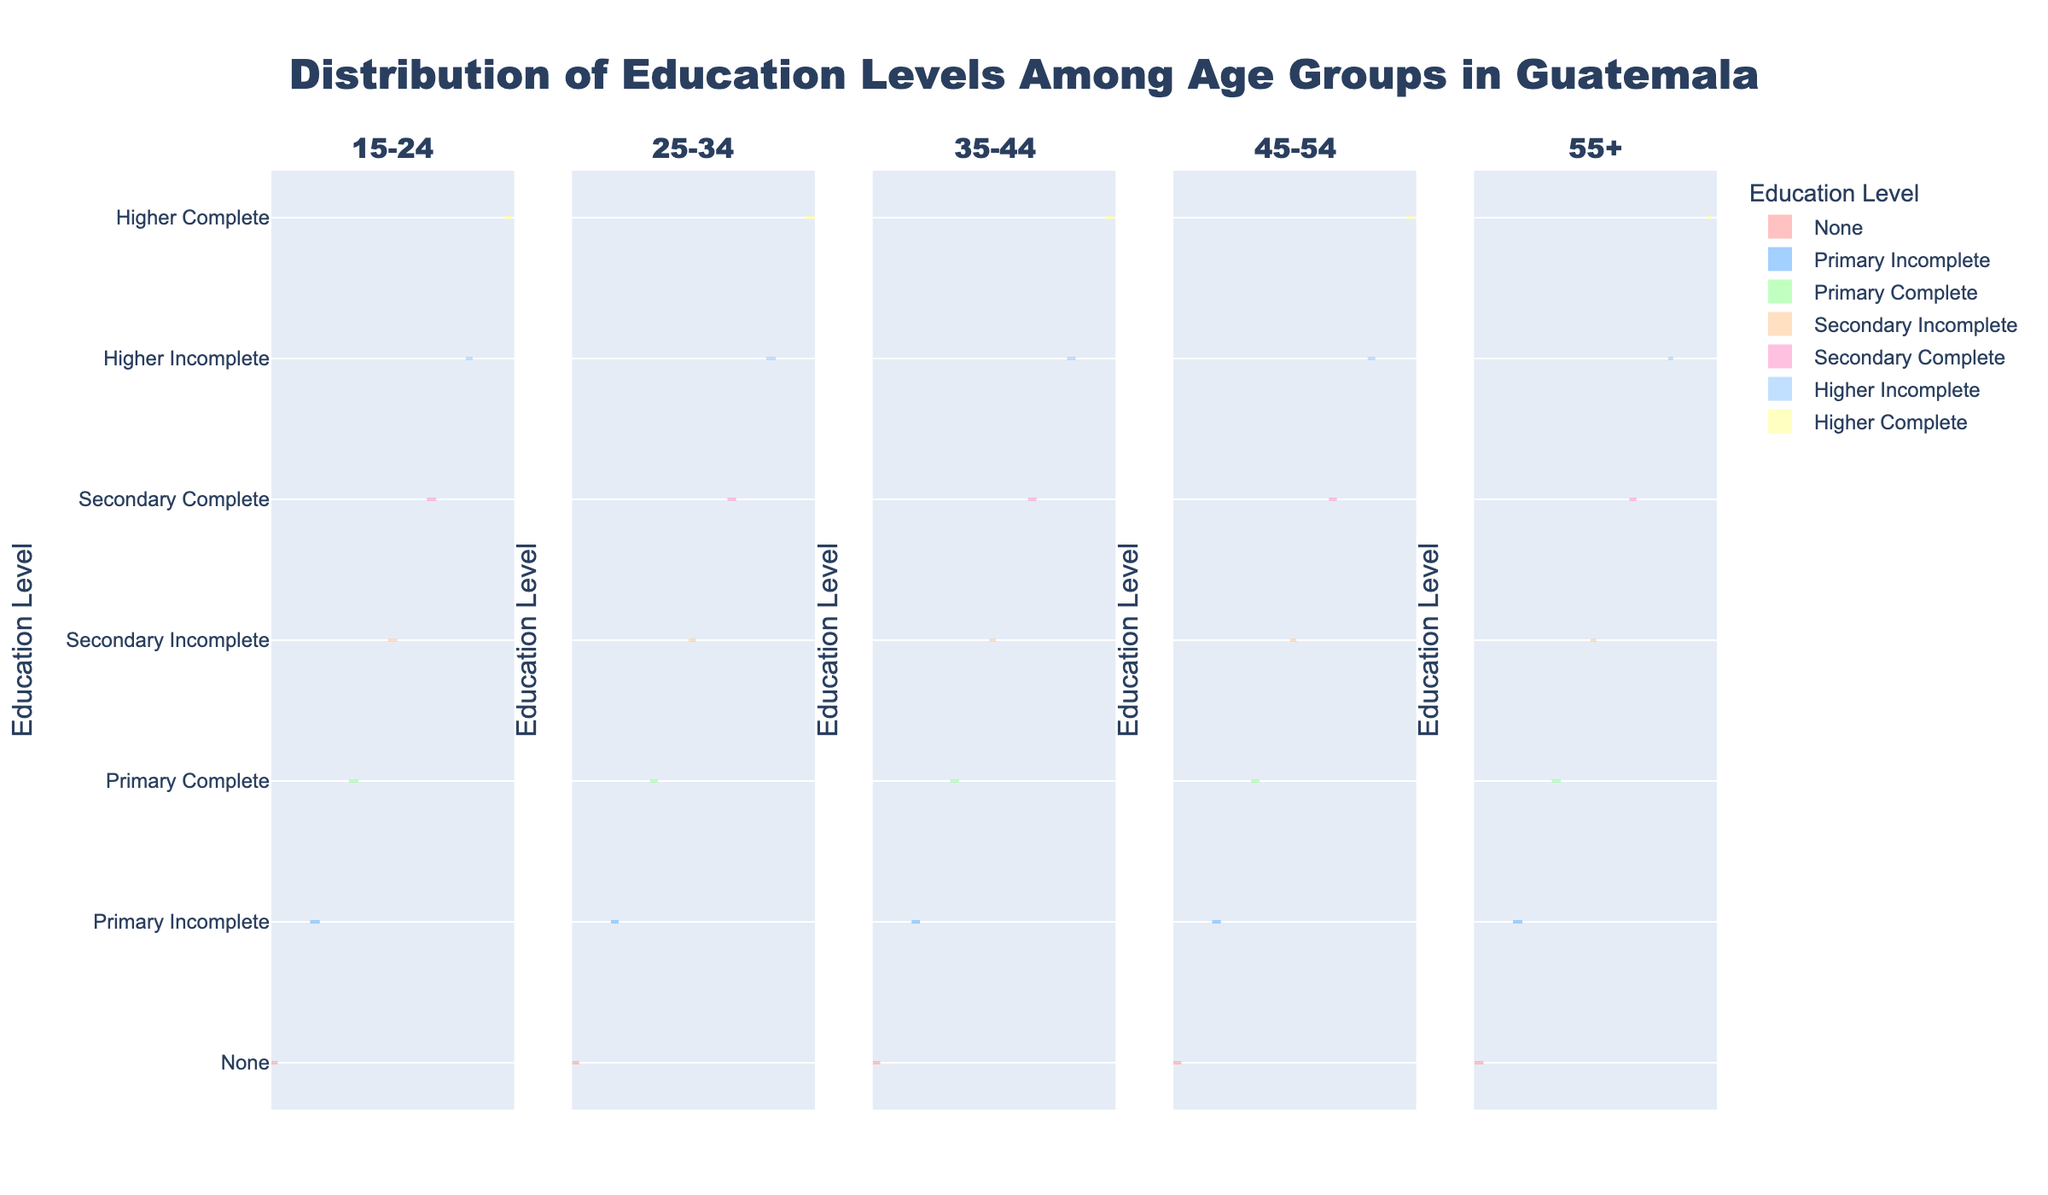What's the title of the figure? The title is typically displayed prominently at the top of the figure.
Answer: Distribution of Education Levels Among Age Groups in Guatemala What does the y-axis represent in the figure? The y-axis label is usually specified on the figure itself.
Answer: Education Level Which age group has the highest frequency of individuals with "Secondary Incomplete" education? By comparing the violin charts for each age group against the education level "Secondary Incomplete," the age group with the widest distribution band represents the highest frequency.
Answer: 15-24 How does the distribution of "Primary Incomplete" education level vary across different age groups? Observe the width of the violin plots for "Primary Incomplete" across the different age group subplots.
Answer: Widest for ages 45-54 and 55+, narrower for younger groups Which educational level has the lowest frequency in the 25-34 age group? The narrowest violin plot in the 25-34 age group subplot indicates the lowest frequency.
Answer: Higher Complete What is the visual difference between the frequency of "None" and "Higher Complete" in the 55+ age group? Compare the width of the violin plots for "None" and "Higher Complete" education levels in the 55+ age group. "None" will be much wider than "Higher Complete" indicating a higher frequency.
Answer: "None" is much higher than "Higher Complete" How does the trend of "Higher Complete" education level vary from the youngest to the oldest age group? Observe the width of the violin plots for "Higher Complete" from the youngest (15-24) to the oldest age group (55+).
Answer: Decreasing trend (whitest for 25-34, narrowest for 55+) Which two age groups have the closest distribution in "Primary Complete" education level? By comparing the widths of the "Primary Complete" violin plots across groups, identify the two closest in width.
Answer: 25-34 and 45-54 In the 35-44 age group, which education level has a higher frequency: "Primary Complete" or "Secondary Complete"? Compare the width of the violin plots for "Primary Complete" and "Secondary Complete" in the 35-44 age group.
Answer: Primary Complete Between 45-54 and 55+, which age group has a higher frequency of individuals with "None" education level? Compare the widths of the violin plots for "None" in the 45-54 and 55+ age groups.
Answer: 55+ 